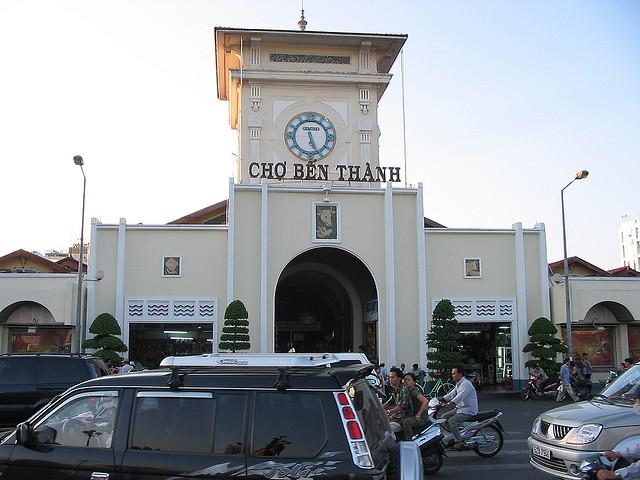Judging from the signage beneath the clock where is this structure located? thailand 